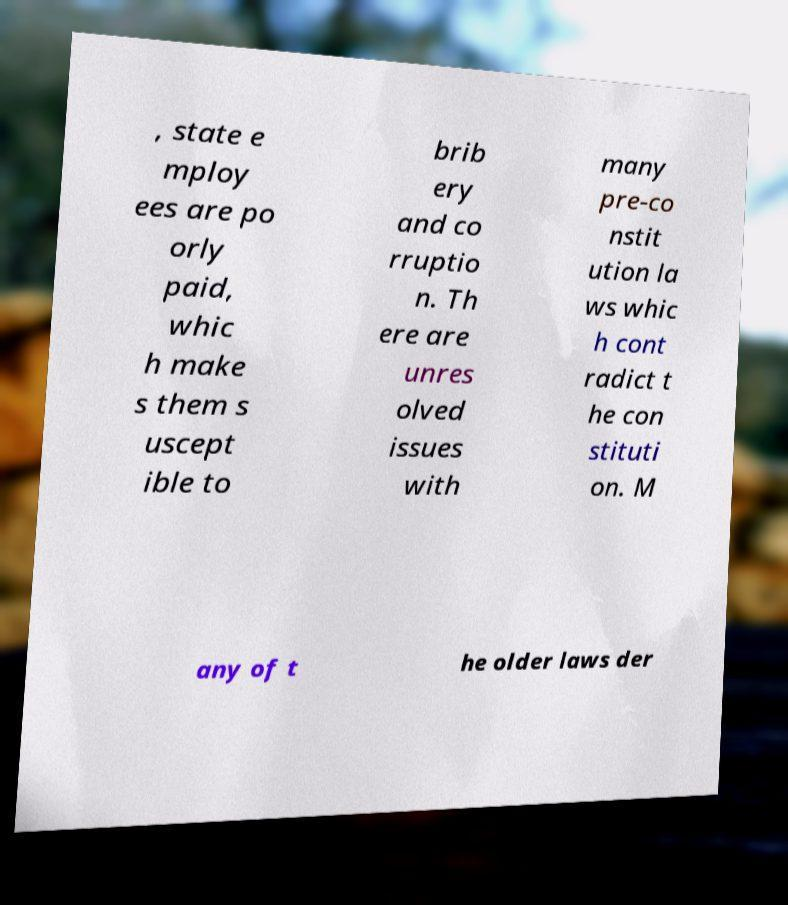Could you assist in decoding the text presented in this image and type it out clearly? , state e mploy ees are po orly paid, whic h make s them s uscept ible to brib ery and co rruptio n. Th ere are unres olved issues with many pre-co nstit ution la ws whic h cont radict t he con stituti on. M any of t he older laws der 